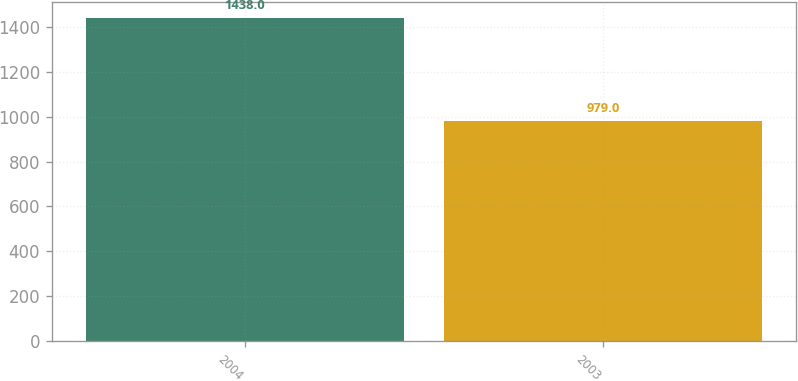Convert chart to OTSL. <chart><loc_0><loc_0><loc_500><loc_500><bar_chart><fcel>2004<fcel>2003<nl><fcel>1438<fcel>979<nl></chart> 